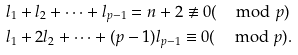Convert formula to latex. <formula><loc_0><loc_0><loc_500><loc_500>& l _ { 1 } + l _ { 2 } + \cdots + l _ { p - 1 } = n + 2 \not \equiv 0 ( \, \mod p ) \\ & l _ { 1 } + 2 l _ { 2 } + \cdots + ( p - 1 ) l _ { p - 1 } \equiv 0 ( \, \mod p ) .</formula> 